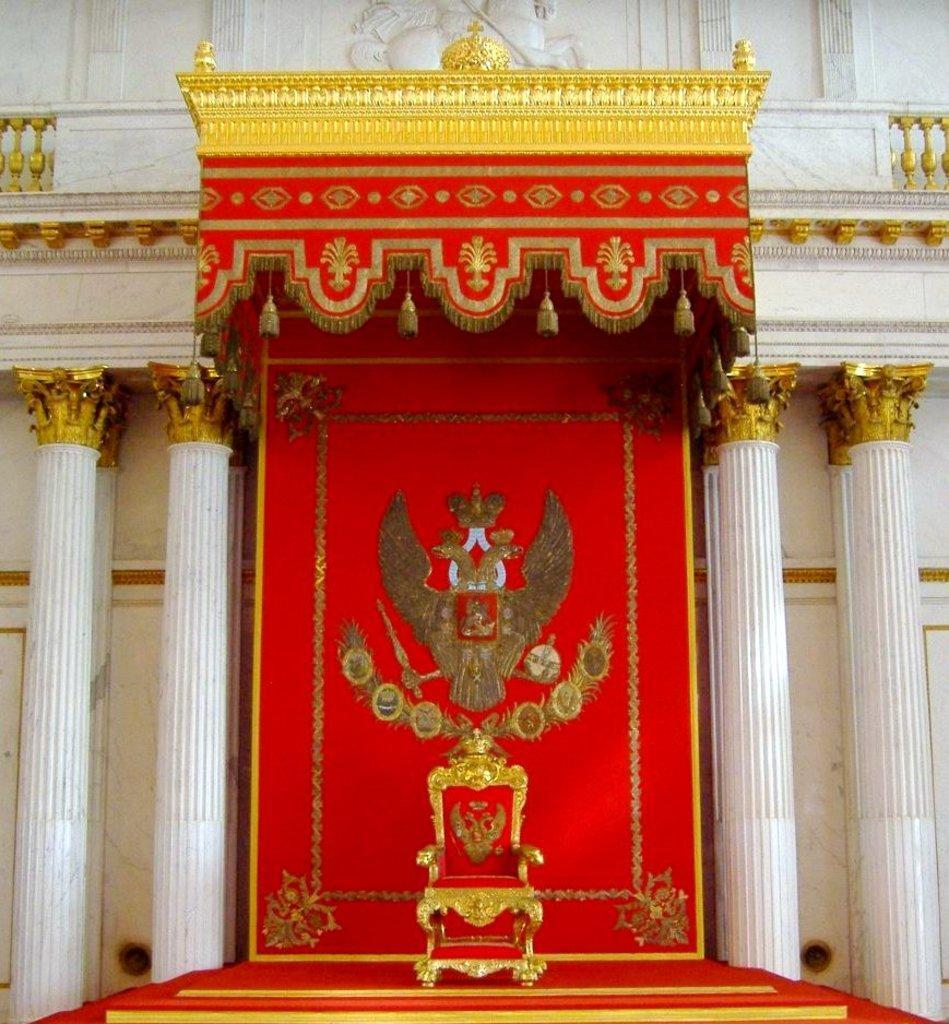How would you summarize this image in a sentence or two? This is the picture of a building. In this image there is a chair and there are pillars and in the foreground there is stair case. At the top there is a sculpture on the wall. 